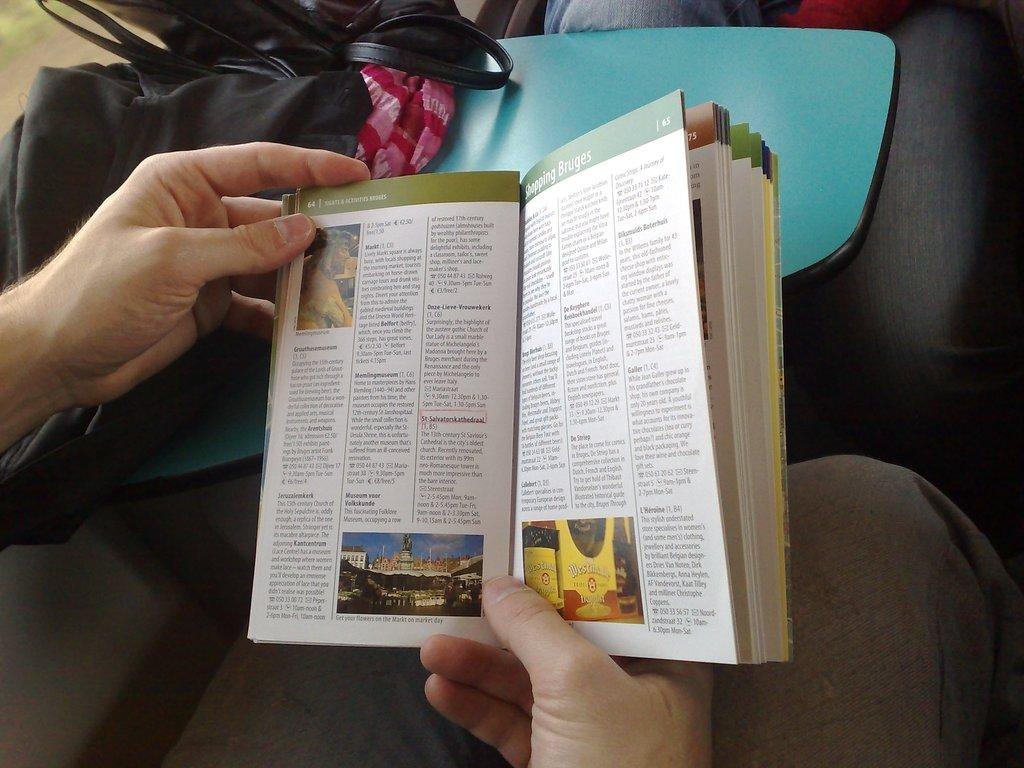Provide a one-sentence caption for the provided image. A travel guide is open to page 65 for shopping Bruges. 